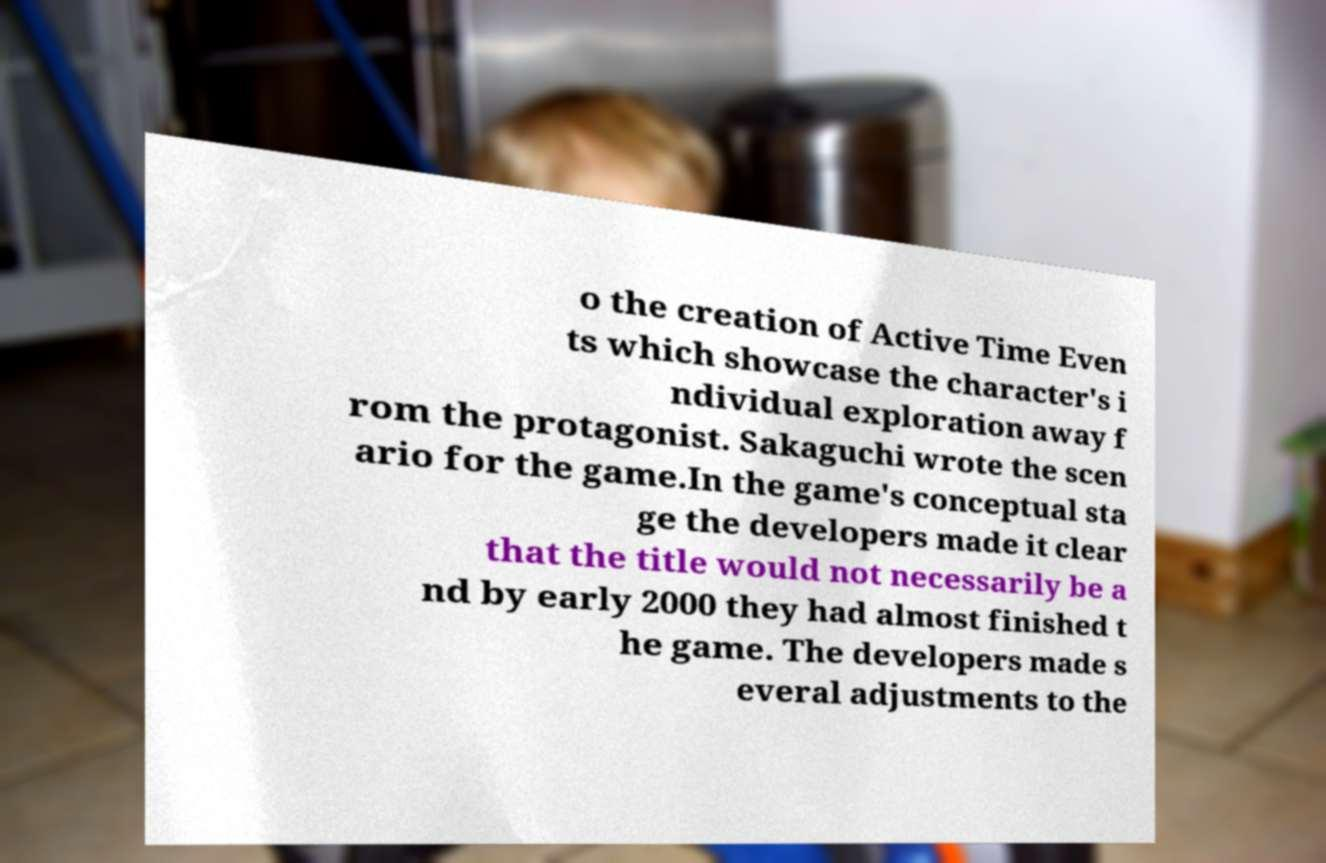Please read and relay the text visible in this image. What does it say? o the creation of Active Time Even ts which showcase the character's i ndividual exploration away f rom the protagonist. Sakaguchi wrote the scen ario for the game.In the game's conceptual sta ge the developers made it clear that the title would not necessarily be a nd by early 2000 they had almost finished t he game. The developers made s everal adjustments to the 